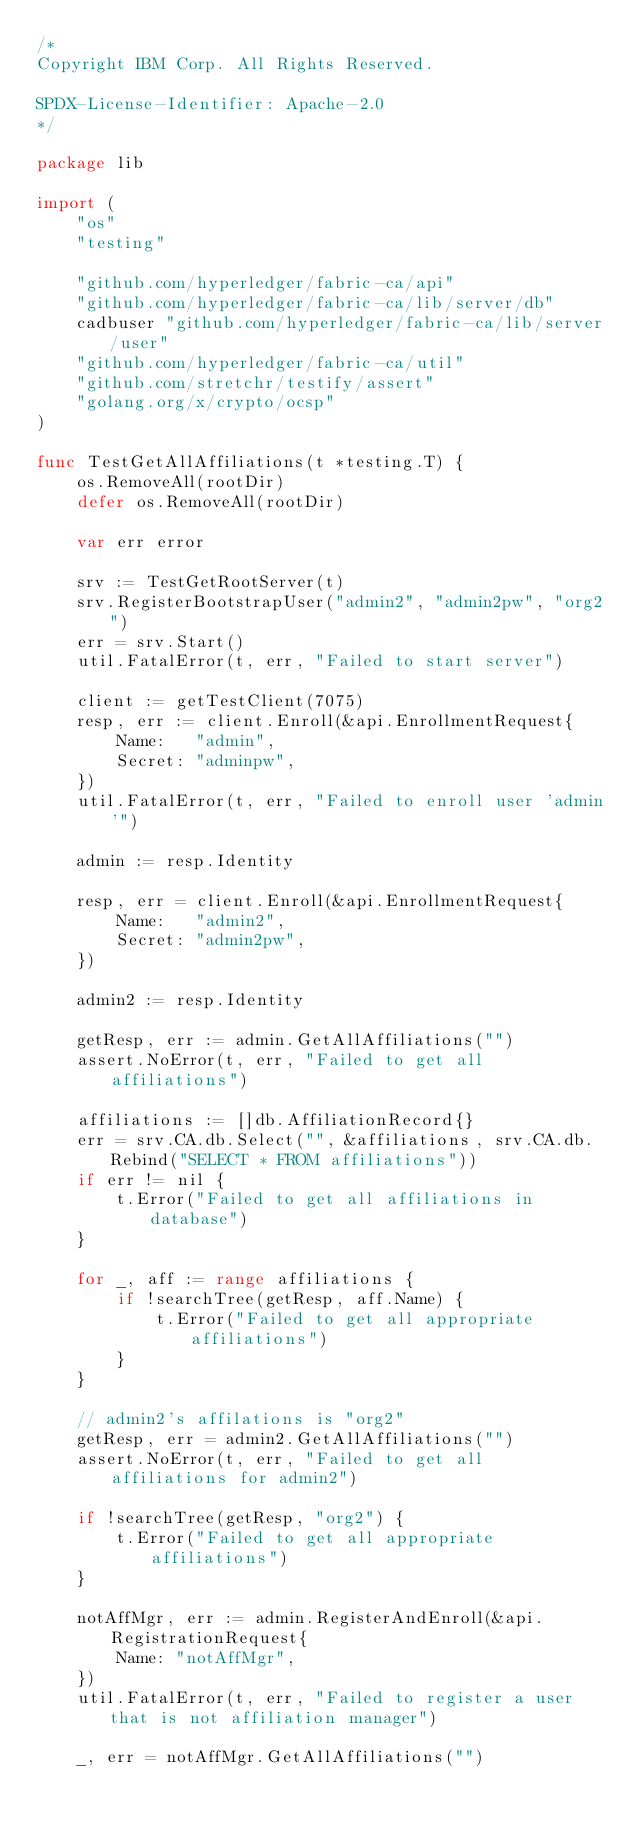<code> <loc_0><loc_0><loc_500><loc_500><_Go_>/*
Copyright IBM Corp. All Rights Reserved.

SPDX-License-Identifier: Apache-2.0
*/

package lib

import (
	"os"
	"testing"

	"github.com/hyperledger/fabric-ca/api"
	"github.com/hyperledger/fabric-ca/lib/server/db"
	cadbuser "github.com/hyperledger/fabric-ca/lib/server/user"
	"github.com/hyperledger/fabric-ca/util"
	"github.com/stretchr/testify/assert"
	"golang.org/x/crypto/ocsp"
)

func TestGetAllAffiliations(t *testing.T) {
	os.RemoveAll(rootDir)
	defer os.RemoveAll(rootDir)

	var err error

	srv := TestGetRootServer(t)
	srv.RegisterBootstrapUser("admin2", "admin2pw", "org2")
	err = srv.Start()
	util.FatalError(t, err, "Failed to start server")

	client := getTestClient(7075)
	resp, err := client.Enroll(&api.EnrollmentRequest{
		Name:   "admin",
		Secret: "adminpw",
	})
	util.FatalError(t, err, "Failed to enroll user 'admin'")

	admin := resp.Identity

	resp, err = client.Enroll(&api.EnrollmentRequest{
		Name:   "admin2",
		Secret: "admin2pw",
	})

	admin2 := resp.Identity

	getResp, err := admin.GetAllAffiliations("")
	assert.NoError(t, err, "Failed to get all affiliations")

	affiliations := []db.AffiliationRecord{}
	err = srv.CA.db.Select("", &affiliations, srv.CA.db.Rebind("SELECT * FROM affiliations"))
	if err != nil {
		t.Error("Failed to get all affiliations in database")
	}

	for _, aff := range affiliations {
		if !searchTree(getResp, aff.Name) {
			t.Error("Failed to get all appropriate affiliations")
		}
	}

	// admin2's affilations is "org2"
	getResp, err = admin2.GetAllAffiliations("")
	assert.NoError(t, err, "Failed to get all affiliations for admin2")

	if !searchTree(getResp, "org2") {
		t.Error("Failed to get all appropriate affiliations")
	}

	notAffMgr, err := admin.RegisterAndEnroll(&api.RegistrationRequest{
		Name: "notAffMgr",
	})
	util.FatalError(t, err, "Failed to register a user that is not affiliation manager")

	_, err = notAffMgr.GetAllAffiliations("")</code> 